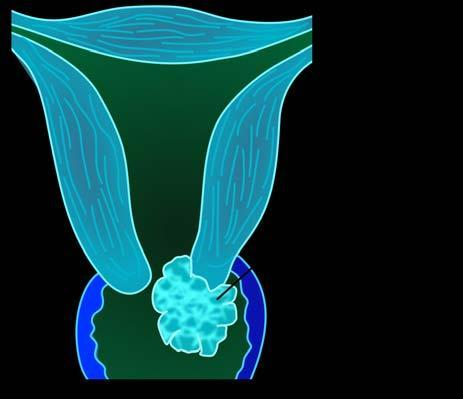what is of a fungating or exophytic, cauliflower-like tumour?
Answer the question using a single word or phrase. Invasive carcinoma of the cervix common gross appearance 